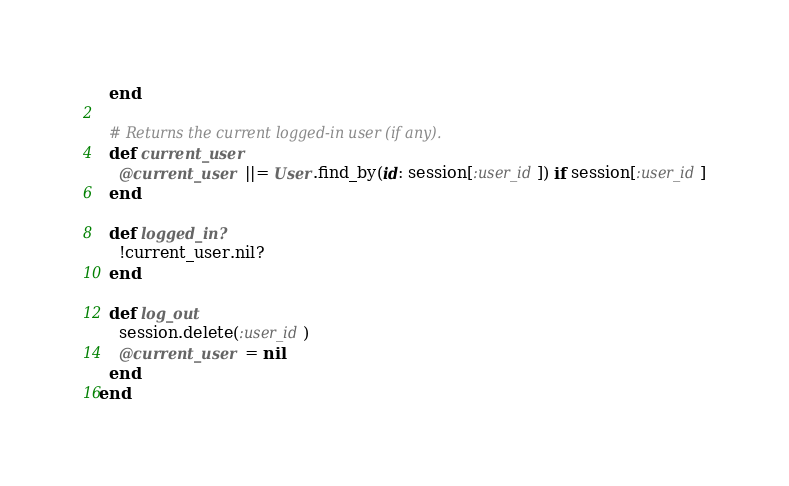<code> <loc_0><loc_0><loc_500><loc_500><_Ruby_>  end

  # Returns the current logged-in user (if any).
  def current_user
    @current_user ||= User.find_by(id: session[:user_id]) if session[:user_id]
  end

  def logged_in?
    !current_user.nil?
  end

  def log_out
    session.delete(:user_id)
    @current_user = nil
  end
end
</code> 